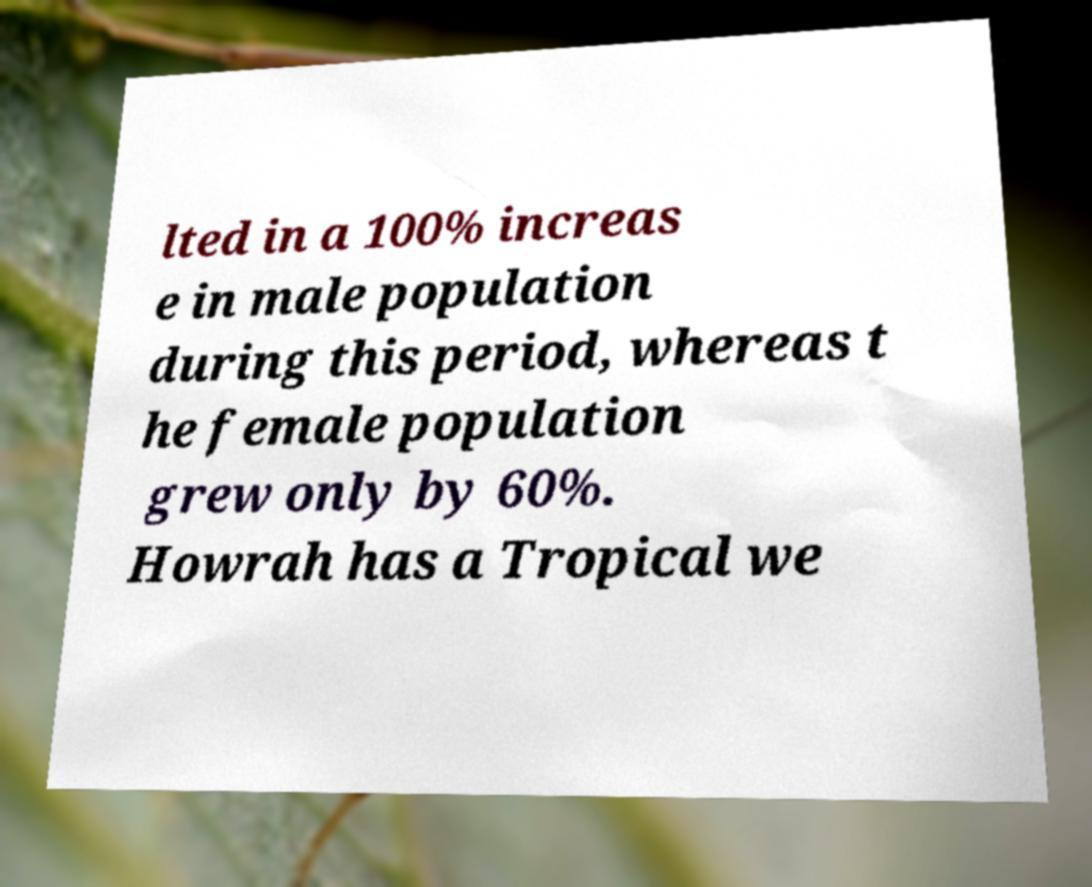Can you read and provide the text displayed in the image?This photo seems to have some interesting text. Can you extract and type it out for me? lted in a 100% increas e in male population during this period, whereas t he female population grew only by 60%. Howrah has a Tropical we 